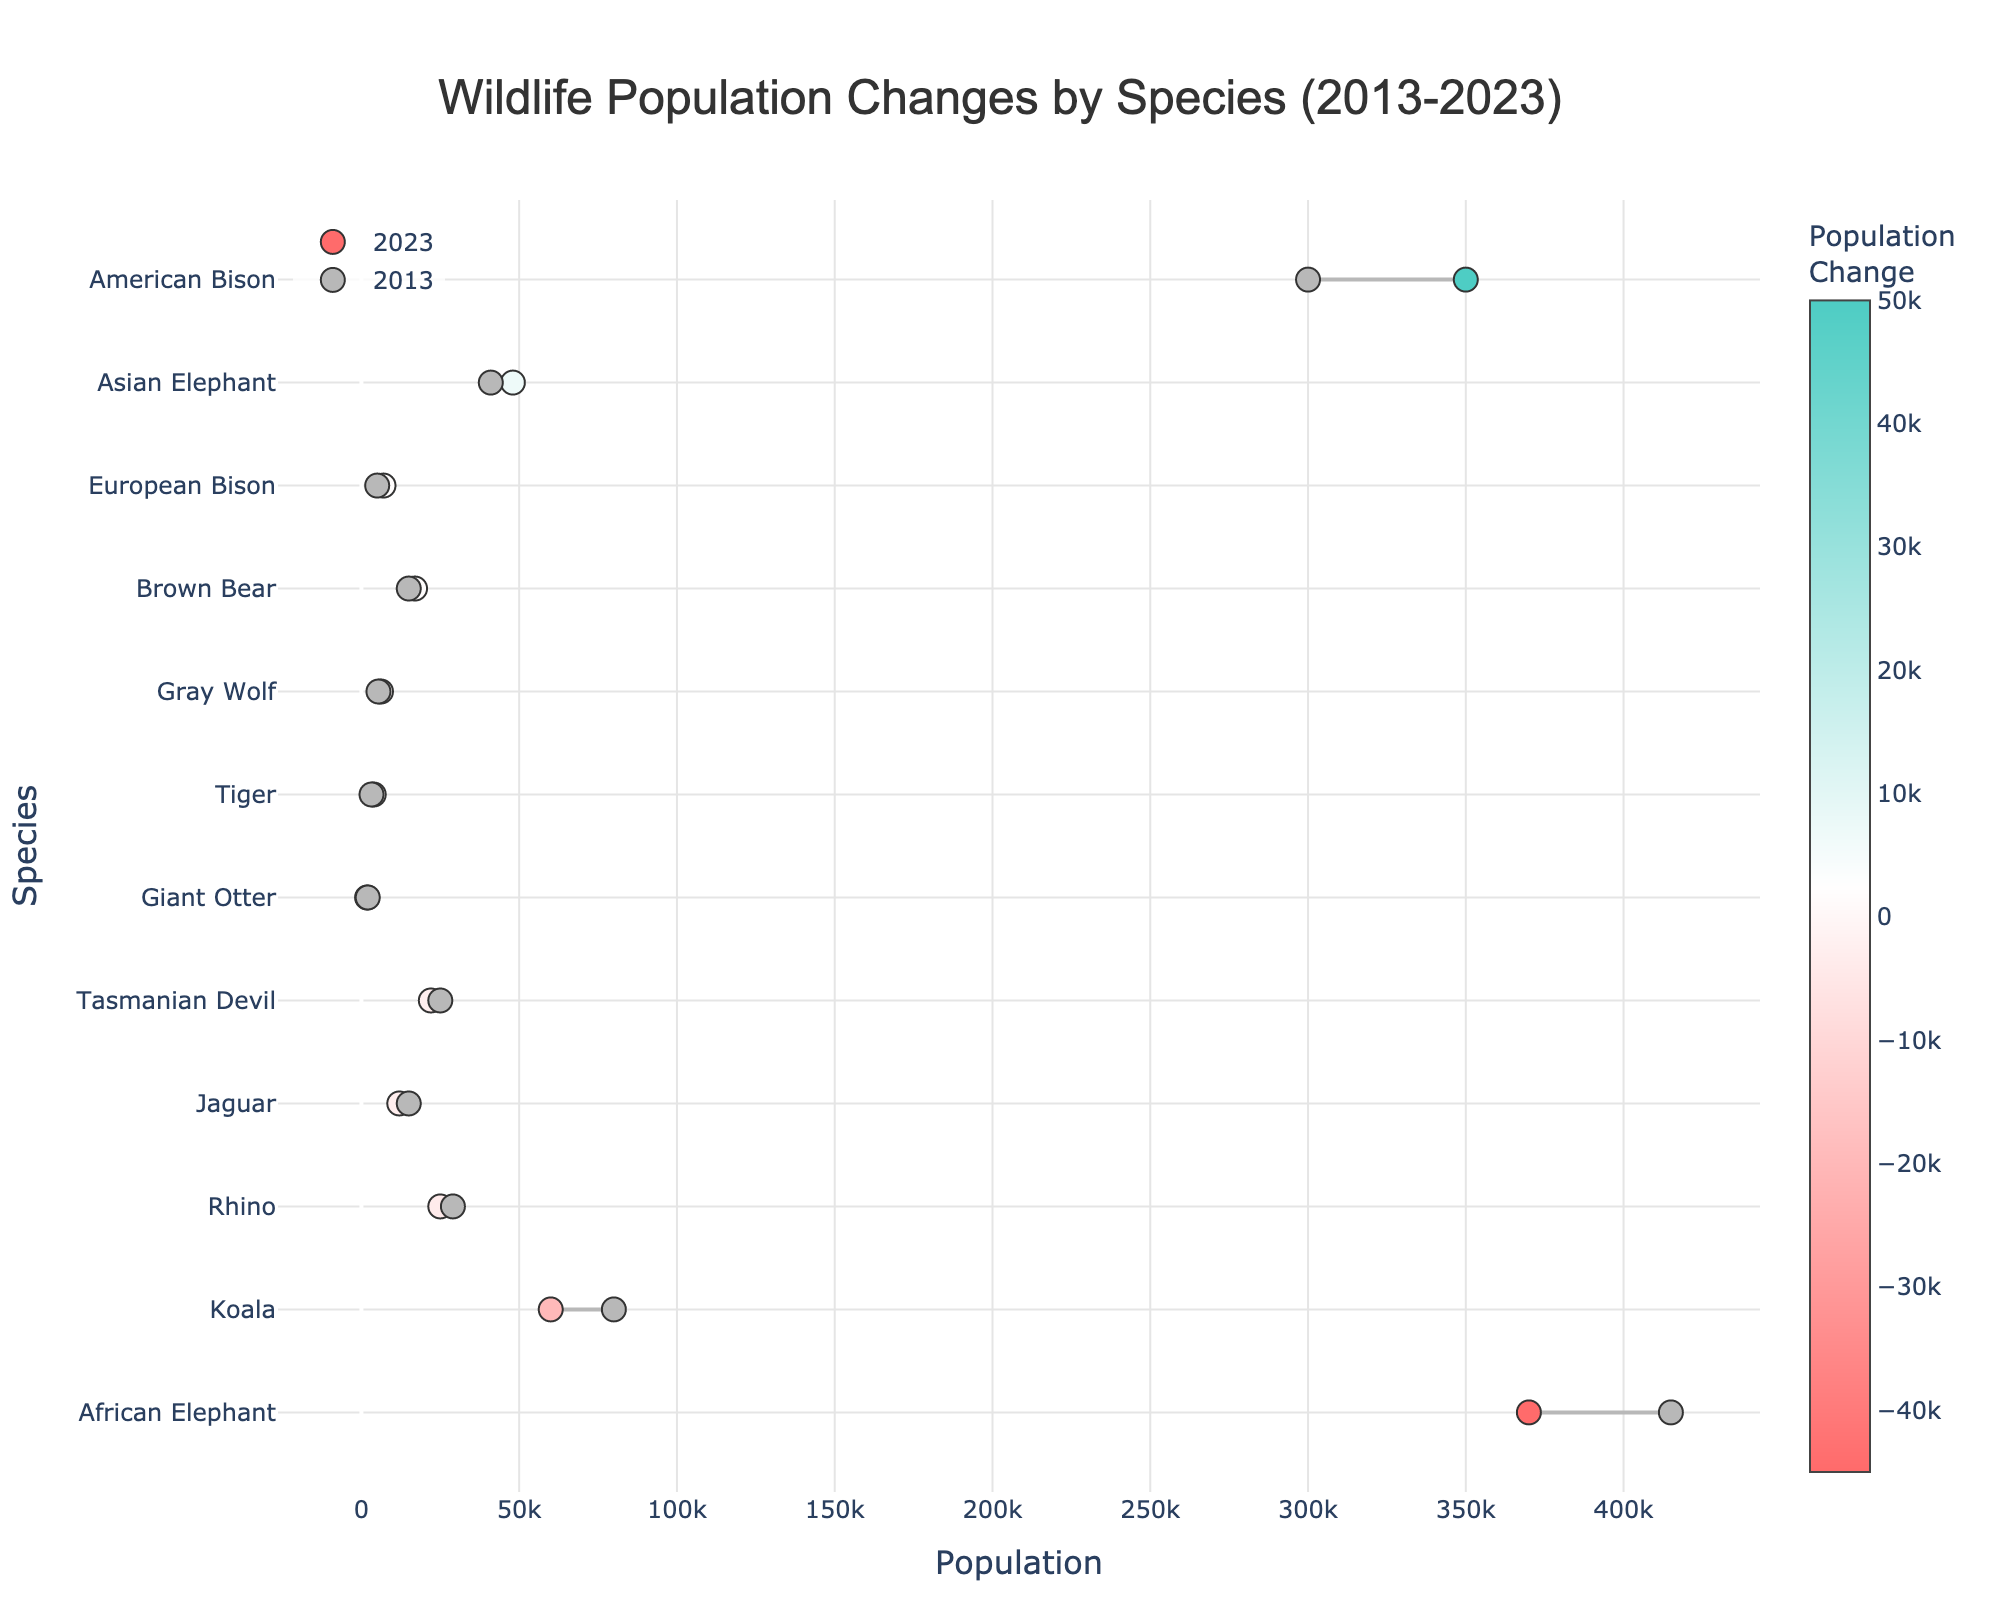What is the title of the plot? The title of the plot is located at the top and it is "Wildlife Population Changes by Species (2013-2023)"
Answer: Wildlife Population Changes by Species (2013-2023) Which species had the largest population increase from 2013 to 2023? By observing the length of the lines and the positions of the markers, the American Bison in North America shows the largest increase in population.
Answer: American Bison Which species shows a reduction in population between 2013 and 2023 in South America? The species in South America with markers indicating a drop in population are the Jaguar and the Giant Otter. The marker positions for these species have moved leftward.
Answer: Jaguar and Giant Otter How much has the population of the African Elephant decreased over the past decade? By looking at the change in the horizontal position of the markers for the African Elephant, we calculate the difference between the 2013 marker at 415,000 and the 2023 marker at 370,000. This difference is 45,000.
Answer: 45,000 Which species in Asia had the higher population increase, the Tiger or the Asian Elephant? The Tiger and Asian Elephant both show an increase, but to determine which is higher, we compare the lengths of the lines. The Tiger increased from 3,200 to 3,900, a change of 700, while the Asian Elephant increased from 41,000 to 48,000, a change of 7,000. Therefore, the Asian Elephant had the higher increase.
Answer: Asian Elephant What is the total population change for species in Europe from 2013 to 2023? For Europe, summing the population changes: Brown Bear increased by 2,000 and European Bison increased by 2,000. Therefore, the total change is 2,000 + 2,000 = 4,000.
Answer: 4,000 How many species experienced a population decline in the past decade? By counting the species with markers indicating a decrease in population (markers moving leftward), we see the Gray Wolf, Jaguar, Giant Otter, African Elephant, Rhino, Koala, and Tasmanian Devil, totaling 7 species.
Answer: 7 Which species had nearly the same population change but different directional trends? The European Bison and the Giant Otter each had a population change of 2,000, but the European Bison's population increased and the Giant Otter's population decreased.
Answer: European Bison and Giant Otter What color is used to represent an increase in population, and what color represents a decrease? For increases in population, greenish colors are used, while reddish colors represent a decrease. This is indicated by the color bar next to the 2023 markers.
Answer: Greenish for increase, Reddish for decrease 